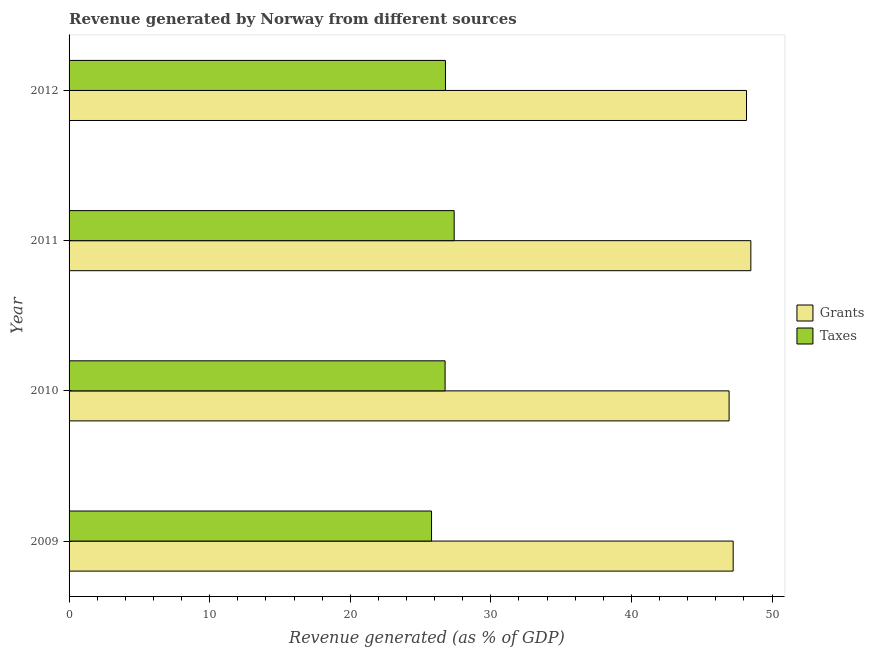Are the number of bars per tick equal to the number of legend labels?
Provide a short and direct response. Yes. How many bars are there on the 3rd tick from the top?
Make the answer very short. 2. What is the label of the 2nd group of bars from the top?
Offer a terse response. 2011. What is the revenue generated by grants in 2010?
Offer a terse response. 46.94. Across all years, what is the maximum revenue generated by grants?
Your answer should be compact. 48.49. Across all years, what is the minimum revenue generated by taxes?
Provide a succinct answer. 25.78. In which year was the revenue generated by taxes maximum?
Your answer should be compact. 2011. What is the total revenue generated by grants in the graph?
Your response must be concise. 190.85. What is the difference between the revenue generated by taxes in 2010 and that in 2011?
Provide a succinct answer. -0.65. What is the difference between the revenue generated by grants in 2009 and the revenue generated by taxes in 2011?
Your answer should be very brief. 19.84. What is the average revenue generated by taxes per year?
Give a very brief answer. 26.67. In the year 2011, what is the difference between the revenue generated by grants and revenue generated by taxes?
Provide a short and direct response. 21.1. In how many years, is the revenue generated by grants greater than 38 %?
Offer a very short reply. 4. What is the ratio of the revenue generated by grants in 2011 to that in 2012?
Provide a succinct answer. 1.01. What is the difference between the highest and the second highest revenue generated by taxes?
Offer a terse response. 0.62. What is the difference between the highest and the lowest revenue generated by taxes?
Ensure brevity in your answer.  1.61. What does the 2nd bar from the top in 2011 represents?
Offer a terse response. Grants. What does the 1st bar from the bottom in 2012 represents?
Make the answer very short. Grants. How many bars are there?
Offer a terse response. 8. How many years are there in the graph?
Ensure brevity in your answer.  4. What is the difference between two consecutive major ticks on the X-axis?
Your answer should be very brief. 10. Are the values on the major ticks of X-axis written in scientific E-notation?
Your response must be concise. No. Does the graph contain any zero values?
Ensure brevity in your answer.  No. Does the graph contain grids?
Your answer should be very brief. No. Where does the legend appear in the graph?
Keep it short and to the point. Center right. How many legend labels are there?
Give a very brief answer. 2. How are the legend labels stacked?
Keep it short and to the point. Vertical. What is the title of the graph?
Offer a very short reply. Revenue generated by Norway from different sources. What is the label or title of the X-axis?
Ensure brevity in your answer.  Revenue generated (as % of GDP). What is the Revenue generated (as % of GDP) of Grants in 2009?
Keep it short and to the point. 47.23. What is the Revenue generated (as % of GDP) of Taxes in 2009?
Your response must be concise. 25.78. What is the Revenue generated (as % of GDP) of Grants in 2010?
Keep it short and to the point. 46.94. What is the Revenue generated (as % of GDP) of Taxes in 2010?
Your answer should be compact. 26.74. What is the Revenue generated (as % of GDP) of Grants in 2011?
Your answer should be very brief. 48.49. What is the Revenue generated (as % of GDP) of Taxes in 2011?
Provide a short and direct response. 27.39. What is the Revenue generated (as % of GDP) in Grants in 2012?
Your response must be concise. 48.18. What is the Revenue generated (as % of GDP) in Taxes in 2012?
Your response must be concise. 26.77. Across all years, what is the maximum Revenue generated (as % of GDP) of Grants?
Give a very brief answer. 48.49. Across all years, what is the maximum Revenue generated (as % of GDP) in Taxes?
Offer a terse response. 27.39. Across all years, what is the minimum Revenue generated (as % of GDP) in Grants?
Your answer should be very brief. 46.94. Across all years, what is the minimum Revenue generated (as % of GDP) of Taxes?
Make the answer very short. 25.78. What is the total Revenue generated (as % of GDP) in Grants in the graph?
Your answer should be very brief. 190.85. What is the total Revenue generated (as % of GDP) in Taxes in the graph?
Keep it short and to the point. 106.69. What is the difference between the Revenue generated (as % of GDP) in Grants in 2009 and that in 2010?
Your answer should be very brief. 0.29. What is the difference between the Revenue generated (as % of GDP) of Taxes in 2009 and that in 2010?
Offer a terse response. -0.96. What is the difference between the Revenue generated (as % of GDP) of Grants in 2009 and that in 2011?
Keep it short and to the point. -1.26. What is the difference between the Revenue generated (as % of GDP) in Taxes in 2009 and that in 2011?
Give a very brief answer. -1.61. What is the difference between the Revenue generated (as % of GDP) of Grants in 2009 and that in 2012?
Offer a very short reply. -0.95. What is the difference between the Revenue generated (as % of GDP) in Taxes in 2009 and that in 2012?
Offer a very short reply. -0.99. What is the difference between the Revenue generated (as % of GDP) of Grants in 2010 and that in 2011?
Ensure brevity in your answer.  -1.55. What is the difference between the Revenue generated (as % of GDP) in Taxes in 2010 and that in 2011?
Provide a succinct answer. -0.65. What is the difference between the Revenue generated (as % of GDP) in Grants in 2010 and that in 2012?
Give a very brief answer. -1.24. What is the difference between the Revenue generated (as % of GDP) in Taxes in 2010 and that in 2012?
Your response must be concise. -0.03. What is the difference between the Revenue generated (as % of GDP) of Grants in 2011 and that in 2012?
Your answer should be compact. 0.31. What is the difference between the Revenue generated (as % of GDP) of Taxes in 2011 and that in 2012?
Your answer should be compact. 0.62. What is the difference between the Revenue generated (as % of GDP) of Grants in 2009 and the Revenue generated (as % of GDP) of Taxes in 2010?
Your answer should be compact. 20.49. What is the difference between the Revenue generated (as % of GDP) in Grants in 2009 and the Revenue generated (as % of GDP) in Taxes in 2011?
Keep it short and to the point. 19.84. What is the difference between the Revenue generated (as % of GDP) in Grants in 2009 and the Revenue generated (as % of GDP) in Taxes in 2012?
Your response must be concise. 20.46. What is the difference between the Revenue generated (as % of GDP) in Grants in 2010 and the Revenue generated (as % of GDP) in Taxes in 2011?
Make the answer very short. 19.55. What is the difference between the Revenue generated (as % of GDP) of Grants in 2010 and the Revenue generated (as % of GDP) of Taxes in 2012?
Your answer should be very brief. 20.17. What is the difference between the Revenue generated (as % of GDP) in Grants in 2011 and the Revenue generated (as % of GDP) in Taxes in 2012?
Your answer should be very brief. 21.72. What is the average Revenue generated (as % of GDP) in Grants per year?
Ensure brevity in your answer.  47.71. What is the average Revenue generated (as % of GDP) in Taxes per year?
Provide a short and direct response. 26.67. In the year 2009, what is the difference between the Revenue generated (as % of GDP) of Grants and Revenue generated (as % of GDP) of Taxes?
Offer a terse response. 21.45. In the year 2010, what is the difference between the Revenue generated (as % of GDP) of Grants and Revenue generated (as % of GDP) of Taxes?
Make the answer very short. 20.2. In the year 2011, what is the difference between the Revenue generated (as % of GDP) of Grants and Revenue generated (as % of GDP) of Taxes?
Keep it short and to the point. 21.1. In the year 2012, what is the difference between the Revenue generated (as % of GDP) in Grants and Revenue generated (as % of GDP) in Taxes?
Offer a terse response. 21.41. What is the ratio of the Revenue generated (as % of GDP) in Grants in 2009 to that in 2011?
Your response must be concise. 0.97. What is the ratio of the Revenue generated (as % of GDP) of Taxes in 2009 to that in 2011?
Your answer should be very brief. 0.94. What is the ratio of the Revenue generated (as % of GDP) of Grants in 2009 to that in 2012?
Offer a very short reply. 0.98. What is the ratio of the Revenue generated (as % of GDP) in Grants in 2010 to that in 2011?
Provide a succinct answer. 0.97. What is the ratio of the Revenue generated (as % of GDP) in Taxes in 2010 to that in 2011?
Provide a short and direct response. 0.98. What is the ratio of the Revenue generated (as % of GDP) in Grants in 2010 to that in 2012?
Make the answer very short. 0.97. What is the ratio of the Revenue generated (as % of GDP) of Grants in 2011 to that in 2012?
Your answer should be compact. 1.01. What is the ratio of the Revenue generated (as % of GDP) of Taxes in 2011 to that in 2012?
Keep it short and to the point. 1.02. What is the difference between the highest and the second highest Revenue generated (as % of GDP) of Grants?
Offer a very short reply. 0.31. What is the difference between the highest and the second highest Revenue generated (as % of GDP) of Taxes?
Provide a succinct answer. 0.62. What is the difference between the highest and the lowest Revenue generated (as % of GDP) of Grants?
Your answer should be very brief. 1.55. What is the difference between the highest and the lowest Revenue generated (as % of GDP) in Taxes?
Give a very brief answer. 1.61. 